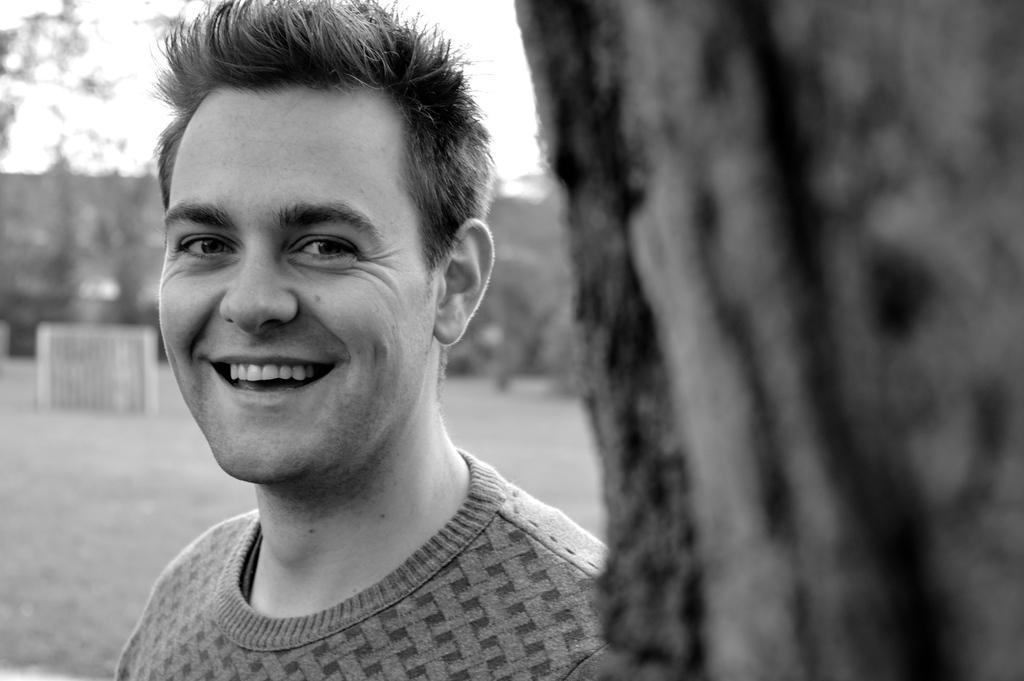Could you give a brief overview of what you see in this image? In the foreground of this black and white image, on the right, there is a tree trunk and behind it, there is a man having smile on his face and the background image is blurred. 